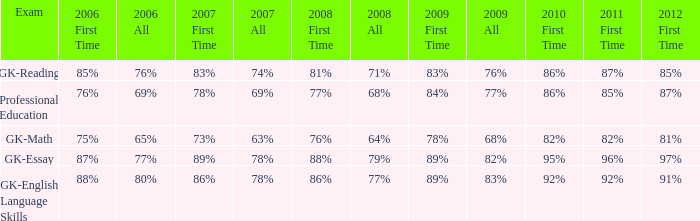What is the percentage for all in 2008 when all in 2007 was 69%? 68%. 